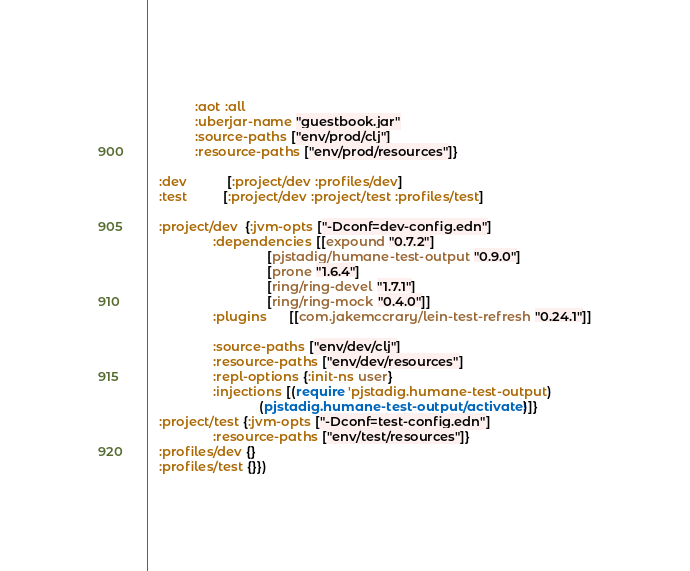<code> <loc_0><loc_0><loc_500><loc_500><_Clojure_>             :aot :all
             :uberjar-name "guestbook.jar"
             :source-paths ["env/prod/clj"]
             :resource-paths ["env/prod/resources"]}

   :dev           [:project/dev :profiles/dev]
   :test          [:project/dev :project/test :profiles/test]

   :project/dev  {:jvm-opts ["-Dconf=dev-config.edn"]
                  :dependencies [[expound "0.7.2"]
                                 [pjstadig/humane-test-output "0.9.0"]
                                 [prone "1.6.4"]
                                 [ring/ring-devel "1.7.1"]
                                 [ring/ring-mock "0.4.0"]]
                  :plugins      [[com.jakemccrary/lein-test-refresh "0.24.1"]]
                  
                  :source-paths ["env/dev/clj"]
                  :resource-paths ["env/dev/resources"]
                  :repl-options {:init-ns user}
                  :injections [(require 'pjstadig.humane-test-output)
                               (pjstadig.humane-test-output/activate!)]}
   :project/test {:jvm-opts ["-Dconf=test-config.edn"]
                  :resource-paths ["env/test/resources"]}
   :profiles/dev {}
   :profiles/test {}})
</code> 